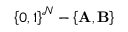Convert formula to latex. <formula><loc_0><loc_0><loc_500><loc_500>\left \{ 0 , 1 \right \} ^ { \mathcal { N } } - \left \{ A , B \right \}</formula> 